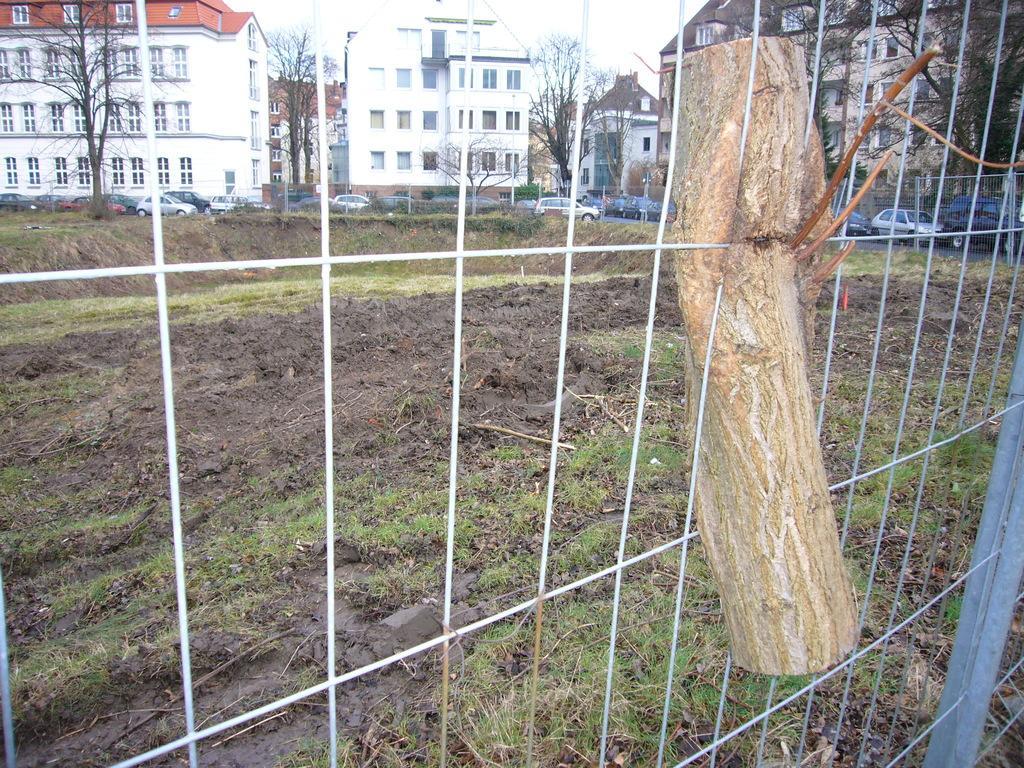How would you summarize this image in a sentence or two? In this image we can see a wooden log to a fence. We can also see some grass on the ground. On the backside we can see some vehicles on the road, a group of trees, a metal fence, some buildings with windows and the sky which looks cloudy. 